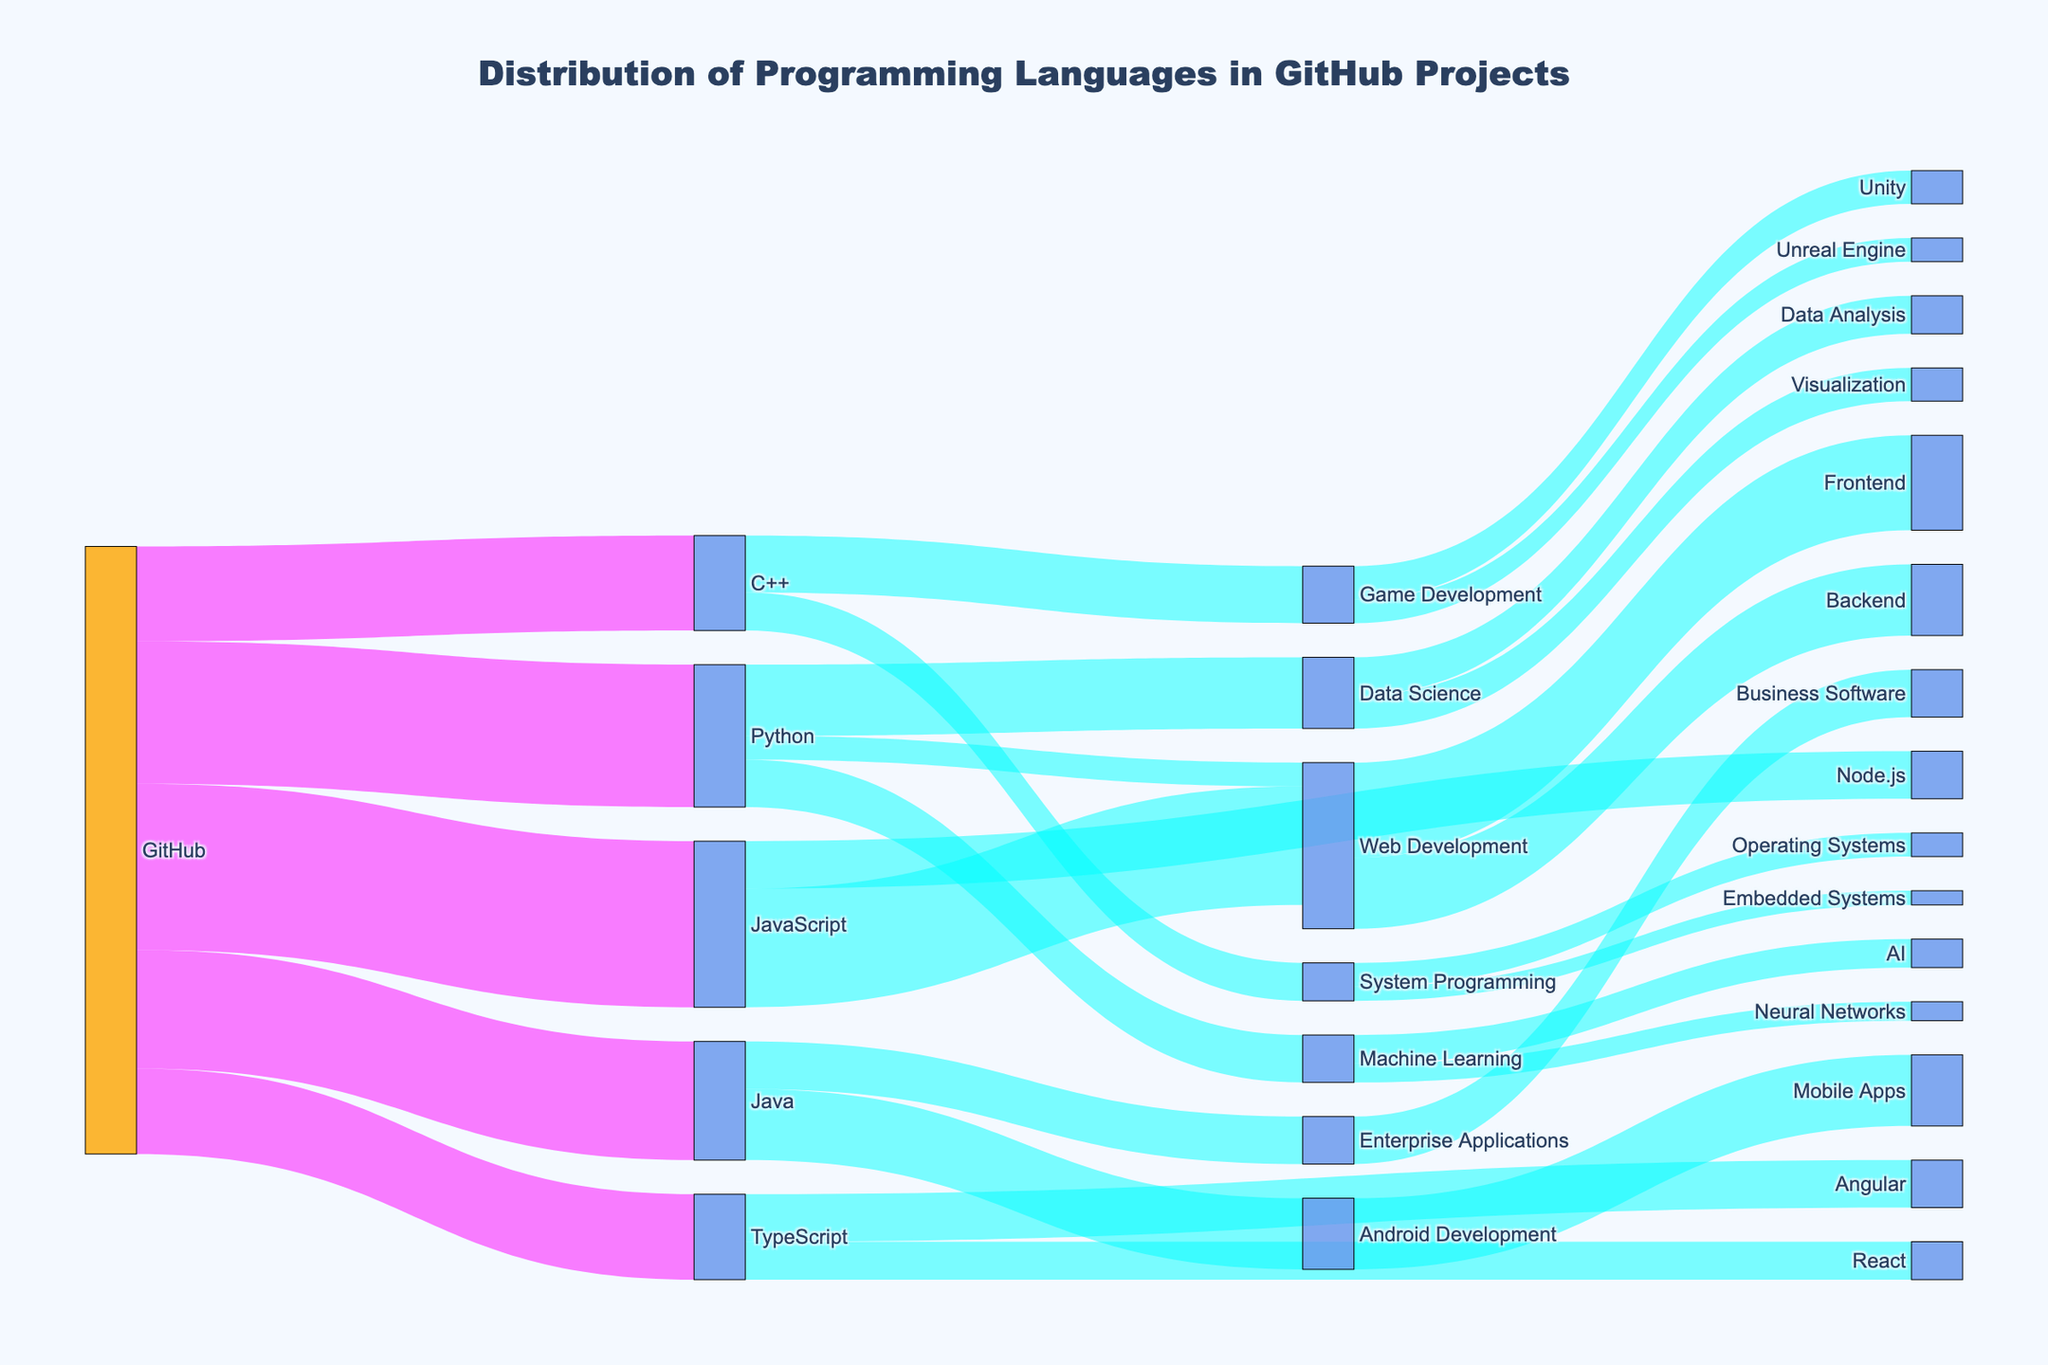what is the title of the figure The title is usually located at the top of the figure. It provides a brief description of what the figure represents. In this case, it is "Distribution of Programming Languages in GitHub Projects."
Answer: Distribution of Programming Languages in GitHub Projects which programming language has the highest usage on GitHub By looking at the node with the highest value directly connected to GitHub, we can see that JavaScript has the highest usage with a value of 35.
Answer: JavaScript what is the total value of Web Development in terms of JavaScript and Python combined To find the total value, we need to sum the contributions of JavaScript and Python to Web Development: JavaScript contributes 25 and Python 5, so the total is 25 + 5 = 30.
Answer: 30 is the value for Data Science from Python greater than for Machine Learning from Python Python contributions to Data Science (value 15) and to Machine Learning (value 10) are compared. Since 15 is greater than 10, the statement is true.
Answer: True which has more projects: Game Development from C++ or Machine Learning from Python By comparing the values from the nodes: Game Development from C++ (12) and Machine Learning from Python (10), we conclude that Game Development from C++ has more projects.
Answer: Game Development from C++ how much more is the contribution of Java to Android Development compared to Enterprise Applications The value for Android Development from Java is 15, and for Enterprise Applications is 10. The difference is 15 - 10 = 5.
Answer: 5 what type of projects does TypeScript contribute to and what are their values TypeScript contributes to Angular with a value of 10 and React with a value of 8.
Answer: Angular (10), React (8) what is the smallest value in the Sankey diagram and which link does it belong to The smallest value is 3, which belongs to the link from System Programming to Embedded Systems.
Answer: Embedded Systems from System Programming (3) which programming language contributes equally to two different types of projects TypeScript contributes equally to both Angular and React, with each having a value of 8.
Answer: TypeScript how many categories directly follow GitHub By counting the distinct targets directly connected to the GitHub source, we find there are 5 categories: JavaScript, Python, Java, C++, and TypeScript.
Answer: 5 